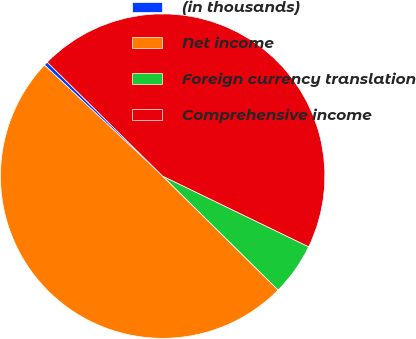Convert chart. <chart><loc_0><loc_0><loc_500><loc_500><pie_chart><fcel>(in thousands)<fcel>Net income<fcel>Foreign currency translation<fcel>Comprehensive income<nl><fcel>0.39%<fcel>49.61%<fcel>5.22%<fcel>44.78%<nl></chart> 